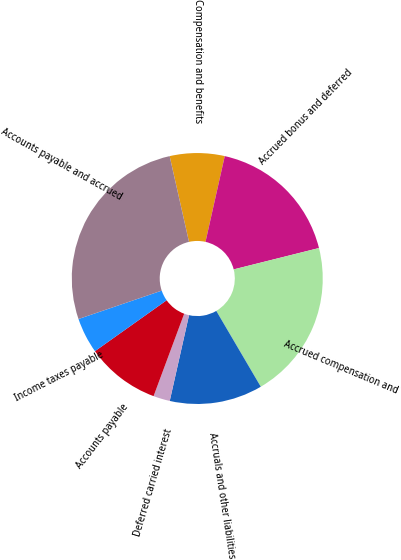Convert chart. <chart><loc_0><loc_0><loc_500><loc_500><pie_chart><fcel>Compensation and benefits<fcel>Accrued bonus and deferred<fcel>Accrued compensation and<fcel>Accruals and other liabilities<fcel>Deferred carried interest<fcel>Accounts payable<fcel>Income taxes payable<fcel>Accounts payable and accrued<nl><fcel>7.05%<fcel>17.58%<fcel>20.46%<fcel>11.97%<fcel>2.14%<fcel>9.51%<fcel>4.6%<fcel>26.7%<nl></chart> 